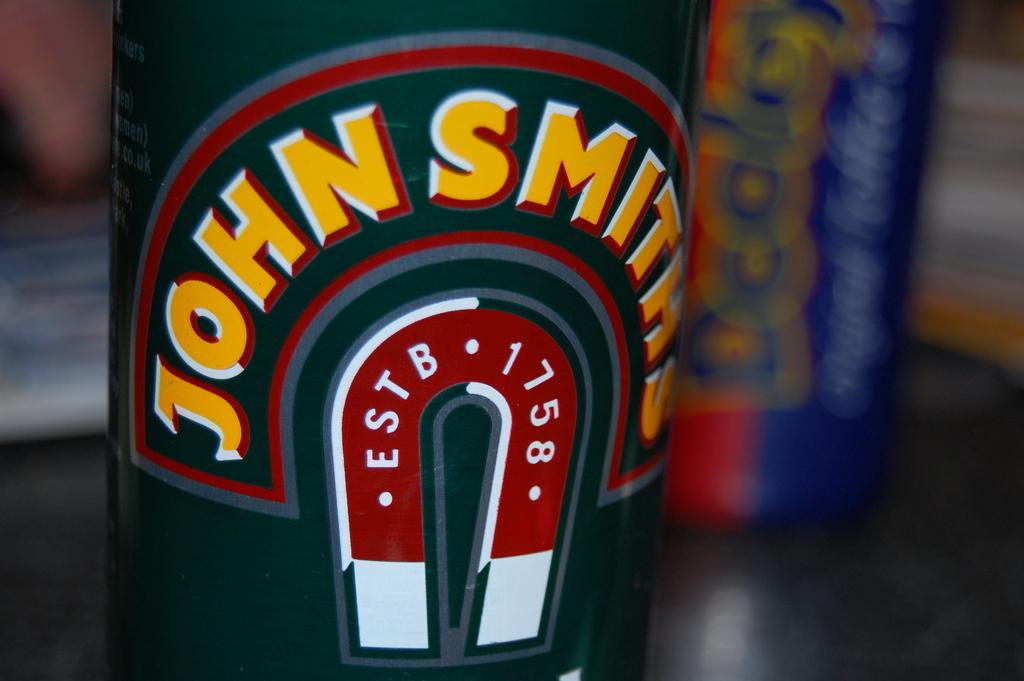<image>
Write a terse but informative summary of the picture. the name John that is on a bottle 